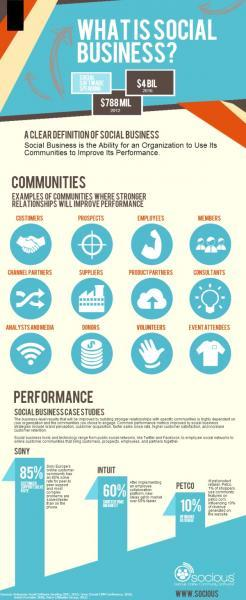Which is the fourth community listed in the infographic?
Answer the question with a short phrase. Members Which is the fifth community listed in the infographic? Suppliers Which is the eleventh community listed in the infographic? Volunteers 